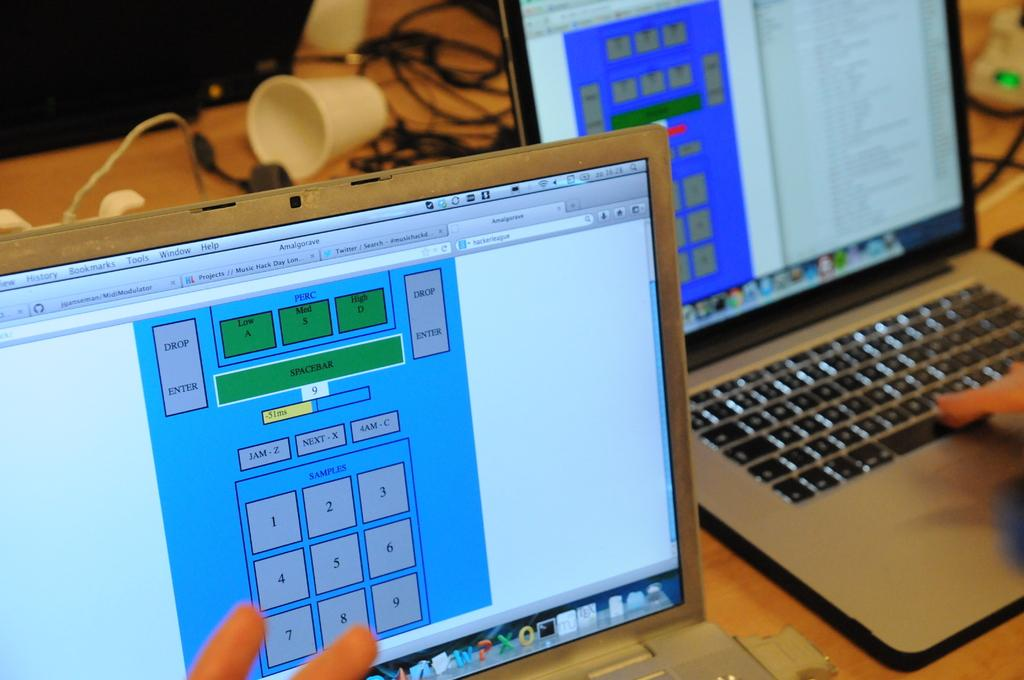<image>
Summarize the visual content of the image. A person touches a monitor which has the phrase Low A on it 